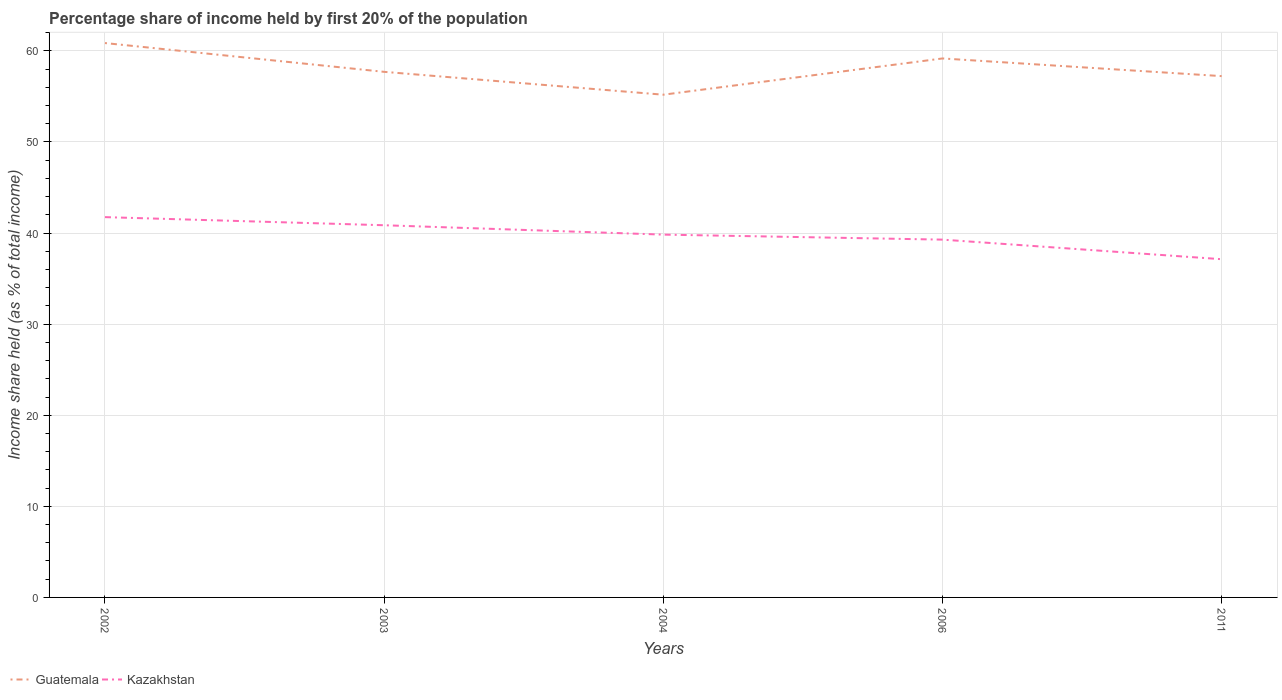Does the line corresponding to Kazakhstan intersect with the line corresponding to Guatemala?
Your answer should be compact. No. Across all years, what is the maximum share of income held by first 20% of the population in Guatemala?
Provide a short and direct response. 55.19. In which year was the share of income held by first 20% of the population in Guatemala maximum?
Provide a short and direct response. 2004. What is the total share of income held by first 20% of the population in Guatemala in the graph?
Make the answer very short. 2.51. What is the difference between the highest and the second highest share of income held by first 20% of the population in Guatemala?
Provide a short and direct response. 5.67. What is the difference between the highest and the lowest share of income held by first 20% of the population in Guatemala?
Your answer should be very brief. 2. Is the share of income held by first 20% of the population in Kazakhstan strictly greater than the share of income held by first 20% of the population in Guatemala over the years?
Offer a terse response. Yes. How many lines are there?
Your answer should be very brief. 2. Where does the legend appear in the graph?
Make the answer very short. Bottom left. What is the title of the graph?
Keep it short and to the point. Percentage share of income held by first 20% of the population. What is the label or title of the X-axis?
Offer a terse response. Years. What is the label or title of the Y-axis?
Provide a succinct answer. Income share held (as % of total income). What is the Income share held (as % of total income) of Guatemala in 2002?
Your answer should be very brief. 60.86. What is the Income share held (as % of total income) in Kazakhstan in 2002?
Offer a terse response. 41.75. What is the Income share held (as % of total income) in Guatemala in 2003?
Give a very brief answer. 57.7. What is the Income share held (as % of total income) of Kazakhstan in 2003?
Your answer should be very brief. 40.86. What is the Income share held (as % of total income) of Guatemala in 2004?
Make the answer very short. 55.19. What is the Income share held (as % of total income) in Kazakhstan in 2004?
Your response must be concise. 39.83. What is the Income share held (as % of total income) in Guatemala in 2006?
Give a very brief answer. 59.17. What is the Income share held (as % of total income) of Kazakhstan in 2006?
Give a very brief answer. 39.28. What is the Income share held (as % of total income) in Guatemala in 2011?
Ensure brevity in your answer.  57.23. What is the Income share held (as % of total income) in Kazakhstan in 2011?
Offer a very short reply. 37.13. Across all years, what is the maximum Income share held (as % of total income) in Guatemala?
Keep it short and to the point. 60.86. Across all years, what is the maximum Income share held (as % of total income) in Kazakhstan?
Ensure brevity in your answer.  41.75. Across all years, what is the minimum Income share held (as % of total income) of Guatemala?
Provide a short and direct response. 55.19. Across all years, what is the minimum Income share held (as % of total income) in Kazakhstan?
Your response must be concise. 37.13. What is the total Income share held (as % of total income) in Guatemala in the graph?
Your answer should be compact. 290.15. What is the total Income share held (as % of total income) in Kazakhstan in the graph?
Offer a terse response. 198.85. What is the difference between the Income share held (as % of total income) in Guatemala in 2002 and that in 2003?
Your answer should be compact. 3.16. What is the difference between the Income share held (as % of total income) in Kazakhstan in 2002 and that in 2003?
Your answer should be compact. 0.89. What is the difference between the Income share held (as % of total income) of Guatemala in 2002 and that in 2004?
Your response must be concise. 5.67. What is the difference between the Income share held (as % of total income) of Kazakhstan in 2002 and that in 2004?
Provide a short and direct response. 1.92. What is the difference between the Income share held (as % of total income) of Guatemala in 2002 and that in 2006?
Give a very brief answer. 1.69. What is the difference between the Income share held (as % of total income) in Kazakhstan in 2002 and that in 2006?
Give a very brief answer. 2.47. What is the difference between the Income share held (as % of total income) of Guatemala in 2002 and that in 2011?
Your response must be concise. 3.63. What is the difference between the Income share held (as % of total income) in Kazakhstan in 2002 and that in 2011?
Your response must be concise. 4.62. What is the difference between the Income share held (as % of total income) of Guatemala in 2003 and that in 2004?
Offer a very short reply. 2.51. What is the difference between the Income share held (as % of total income) in Kazakhstan in 2003 and that in 2004?
Your answer should be compact. 1.03. What is the difference between the Income share held (as % of total income) in Guatemala in 2003 and that in 2006?
Offer a terse response. -1.47. What is the difference between the Income share held (as % of total income) in Kazakhstan in 2003 and that in 2006?
Provide a succinct answer. 1.58. What is the difference between the Income share held (as % of total income) in Guatemala in 2003 and that in 2011?
Your answer should be very brief. 0.47. What is the difference between the Income share held (as % of total income) in Kazakhstan in 2003 and that in 2011?
Ensure brevity in your answer.  3.73. What is the difference between the Income share held (as % of total income) of Guatemala in 2004 and that in 2006?
Keep it short and to the point. -3.98. What is the difference between the Income share held (as % of total income) in Kazakhstan in 2004 and that in 2006?
Offer a very short reply. 0.55. What is the difference between the Income share held (as % of total income) of Guatemala in 2004 and that in 2011?
Offer a terse response. -2.04. What is the difference between the Income share held (as % of total income) of Kazakhstan in 2004 and that in 2011?
Offer a terse response. 2.7. What is the difference between the Income share held (as % of total income) of Guatemala in 2006 and that in 2011?
Your answer should be very brief. 1.94. What is the difference between the Income share held (as % of total income) of Kazakhstan in 2006 and that in 2011?
Offer a very short reply. 2.15. What is the difference between the Income share held (as % of total income) of Guatemala in 2002 and the Income share held (as % of total income) of Kazakhstan in 2003?
Provide a succinct answer. 20. What is the difference between the Income share held (as % of total income) of Guatemala in 2002 and the Income share held (as % of total income) of Kazakhstan in 2004?
Offer a very short reply. 21.03. What is the difference between the Income share held (as % of total income) of Guatemala in 2002 and the Income share held (as % of total income) of Kazakhstan in 2006?
Your answer should be compact. 21.58. What is the difference between the Income share held (as % of total income) of Guatemala in 2002 and the Income share held (as % of total income) of Kazakhstan in 2011?
Give a very brief answer. 23.73. What is the difference between the Income share held (as % of total income) in Guatemala in 2003 and the Income share held (as % of total income) in Kazakhstan in 2004?
Your answer should be compact. 17.87. What is the difference between the Income share held (as % of total income) in Guatemala in 2003 and the Income share held (as % of total income) in Kazakhstan in 2006?
Give a very brief answer. 18.42. What is the difference between the Income share held (as % of total income) of Guatemala in 2003 and the Income share held (as % of total income) of Kazakhstan in 2011?
Your answer should be very brief. 20.57. What is the difference between the Income share held (as % of total income) of Guatemala in 2004 and the Income share held (as % of total income) of Kazakhstan in 2006?
Offer a very short reply. 15.91. What is the difference between the Income share held (as % of total income) in Guatemala in 2004 and the Income share held (as % of total income) in Kazakhstan in 2011?
Keep it short and to the point. 18.06. What is the difference between the Income share held (as % of total income) in Guatemala in 2006 and the Income share held (as % of total income) in Kazakhstan in 2011?
Your answer should be compact. 22.04. What is the average Income share held (as % of total income) in Guatemala per year?
Ensure brevity in your answer.  58.03. What is the average Income share held (as % of total income) in Kazakhstan per year?
Your answer should be compact. 39.77. In the year 2002, what is the difference between the Income share held (as % of total income) of Guatemala and Income share held (as % of total income) of Kazakhstan?
Your response must be concise. 19.11. In the year 2003, what is the difference between the Income share held (as % of total income) in Guatemala and Income share held (as % of total income) in Kazakhstan?
Your answer should be compact. 16.84. In the year 2004, what is the difference between the Income share held (as % of total income) in Guatemala and Income share held (as % of total income) in Kazakhstan?
Give a very brief answer. 15.36. In the year 2006, what is the difference between the Income share held (as % of total income) of Guatemala and Income share held (as % of total income) of Kazakhstan?
Offer a very short reply. 19.89. In the year 2011, what is the difference between the Income share held (as % of total income) of Guatemala and Income share held (as % of total income) of Kazakhstan?
Your answer should be very brief. 20.1. What is the ratio of the Income share held (as % of total income) of Guatemala in 2002 to that in 2003?
Give a very brief answer. 1.05. What is the ratio of the Income share held (as % of total income) of Kazakhstan in 2002 to that in 2003?
Keep it short and to the point. 1.02. What is the ratio of the Income share held (as % of total income) in Guatemala in 2002 to that in 2004?
Ensure brevity in your answer.  1.1. What is the ratio of the Income share held (as % of total income) in Kazakhstan in 2002 to that in 2004?
Provide a short and direct response. 1.05. What is the ratio of the Income share held (as % of total income) of Guatemala in 2002 to that in 2006?
Keep it short and to the point. 1.03. What is the ratio of the Income share held (as % of total income) of Kazakhstan in 2002 to that in 2006?
Offer a terse response. 1.06. What is the ratio of the Income share held (as % of total income) of Guatemala in 2002 to that in 2011?
Your answer should be very brief. 1.06. What is the ratio of the Income share held (as % of total income) in Kazakhstan in 2002 to that in 2011?
Make the answer very short. 1.12. What is the ratio of the Income share held (as % of total income) of Guatemala in 2003 to that in 2004?
Keep it short and to the point. 1.05. What is the ratio of the Income share held (as % of total income) of Kazakhstan in 2003 to that in 2004?
Keep it short and to the point. 1.03. What is the ratio of the Income share held (as % of total income) of Guatemala in 2003 to that in 2006?
Give a very brief answer. 0.98. What is the ratio of the Income share held (as % of total income) of Kazakhstan in 2003 to that in 2006?
Make the answer very short. 1.04. What is the ratio of the Income share held (as % of total income) of Guatemala in 2003 to that in 2011?
Offer a terse response. 1.01. What is the ratio of the Income share held (as % of total income) of Kazakhstan in 2003 to that in 2011?
Ensure brevity in your answer.  1.1. What is the ratio of the Income share held (as % of total income) of Guatemala in 2004 to that in 2006?
Your response must be concise. 0.93. What is the ratio of the Income share held (as % of total income) of Guatemala in 2004 to that in 2011?
Give a very brief answer. 0.96. What is the ratio of the Income share held (as % of total income) in Kazakhstan in 2004 to that in 2011?
Make the answer very short. 1.07. What is the ratio of the Income share held (as % of total income) in Guatemala in 2006 to that in 2011?
Offer a terse response. 1.03. What is the ratio of the Income share held (as % of total income) in Kazakhstan in 2006 to that in 2011?
Your response must be concise. 1.06. What is the difference between the highest and the second highest Income share held (as % of total income) in Guatemala?
Ensure brevity in your answer.  1.69. What is the difference between the highest and the second highest Income share held (as % of total income) in Kazakhstan?
Provide a short and direct response. 0.89. What is the difference between the highest and the lowest Income share held (as % of total income) in Guatemala?
Provide a short and direct response. 5.67. What is the difference between the highest and the lowest Income share held (as % of total income) in Kazakhstan?
Your answer should be very brief. 4.62. 